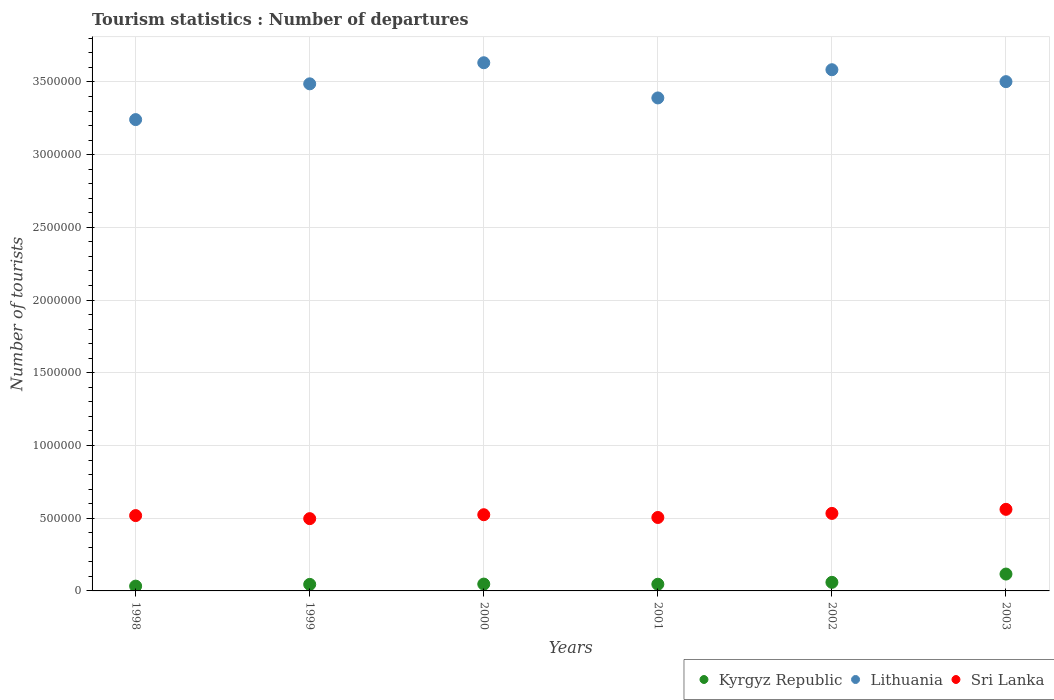Is the number of dotlines equal to the number of legend labels?
Your answer should be very brief. Yes. What is the number of tourist departures in Sri Lanka in 1999?
Keep it short and to the point. 4.97e+05. Across all years, what is the maximum number of tourist departures in Sri Lanka?
Provide a succinct answer. 5.61e+05. Across all years, what is the minimum number of tourist departures in Sri Lanka?
Offer a terse response. 4.97e+05. In which year was the number of tourist departures in Kyrgyz Republic maximum?
Your response must be concise. 2003. In which year was the number of tourist departures in Lithuania minimum?
Provide a succinct answer. 1998. What is the total number of tourist departures in Sri Lanka in the graph?
Make the answer very short. 3.14e+06. What is the difference between the number of tourist departures in Kyrgyz Republic in 2001 and that in 2003?
Keep it short and to the point. -7.00e+04. What is the difference between the number of tourist departures in Sri Lanka in 1998 and the number of tourist departures in Kyrgyz Republic in 2003?
Your answer should be very brief. 4.02e+05. What is the average number of tourist departures in Lithuania per year?
Provide a succinct answer. 3.47e+06. In the year 2001, what is the difference between the number of tourist departures in Lithuania and number of tourist departures in Kyrgyz Republic?
Give a very brief answer. 3.34e+06. What is the ratio of the number of tourist departures in Lithuania in 2000 to that in 2002?
Your response must be concise. 1.01. Is the number of tourist departures in Kyrgyz Republic in 2001 less than that in 2002?
Give a very brief answer. Yes. What is the difference between the highest and the second highest number of tourist departures in Kyrgyz Republic?
Give a very brief answer. 5.70e+04. What is the difference between the highest and the lowest number of tourist departures in Kyrgyz Republic?
Your response must be concise. 8.30e+04. Is it the case that in every year, the sum of the number of tourist departures in Kyrgyz Republic and number of tourist departures in Lithuania  is greater than the number of tourist departures in Sri Lanka?
Provide a short and direct response. Yes. Does the number of tourist departures in Lithuania monotonically increase over the years?
Ensure brevity in your answer.  No. What is the difference between two consecutive major ticks on the Y-axis?
Provide a succinct answer. 5.00e+05. Does the graph contain any zero values?
Give a very brief answer. No. How many legend labels are there?
Your answer should be very brief. 3. What is the title of the graph?
Offer a terse response. Tourism statistics : Number of departures. Does "Italy" appear as one of the legend labels in the graph?
Provide a succinct answer. No. What is the label or title of the X-axis?
Your answer should be very brief. Years. What is the label or title of the Y-axis?
Your answer should be compact. Number of tourists. What is the Number of tourists in Kyrgyz Republic in 1998?
Ensure brevity in your answer.  3.30e+04. What is the Number of tourists of Lithuania in 1998?
Your response must be concise. 3.24e+06. What is the Number of tourists of Sri Lanka in 1998?
Keep it short and to the point. 5.18e+05. What is the Number of tourists in Kyrgyz Republic in 1999?
Keep it short and to the point. 4.50e+04. What is the Number of tourists of Lithuania in 1999?
Your answer should be very brief. 3.49e+06. What is the Number of tourists in Sri Lanka in 1999?
Offer a very short reply. 4.97e+05. What is the Number of tourists of Kyrgyz Republic in 2000?
Give a very brief answer. 4.70e+04. What is the Number of tourists of Lithuania in 2000?
Your answer should be compact. 3.63e+06. What is the Number of tourists of Sri Lanka in 2000?
Give a very brief answer. 5.24e+05. What is the Number of tourists in Kyrgyz Republic in 2001?
Keep it short and to the point. 4.60e+04. What is the Number of tourists in Lithuania in 2001?
Offer a terse response. 3.39e+06. What is the Number of tourists of Sri Lanka in 2001?
Make the answer very short. 5.05e+05. What is the Number of tourists of Kyrgyz Republic in 2002?
Your answer should be very brief. 5.90e+04. What is the Number of tourists of Lithuania in 2002?
Provide a succinct answer. 3.58e+06. What is the Number of tourists of Sri Lanka in 2002?
Keep it short and to the point. 5.33e+05. What is the Number of tourists in Kyrgyz Republic in 2003?
Offer a very short reply. 1.16e+05. What is the Number of tourists of Lithuania in 2003?
Offer a terse response. 3.50e+06. What is the Number of tourists in Sri Lanka in 2003?
Your answer should be very brief. 5.61e+05. Across all years, what is the maximum Number of tourists in Kyrgyz Republic?
Give a very brief answer. 1.16e+05. Across all years, what is the maximum Number of tourists in Lithuania?
Your answer should be compact. 3.63e+06. Across all years, what is the maximum Number of tourists of Sri Lanka?
Ensure brevity in your answer.  5.61e+05. Across all years, what is the minimum Number of tourists of Kyrgyz Republic?
Offer a very short reply. 3.30e+04. Across all years, what is the minimum Number of tourists in Lithuania?
Your response must be concise. 3.24e+06. Across all years, what is the minimum Number of tourists in Sri Lanka?
Ensure brevity in your answer.  4.97e+05. What is the total Number of tourists in Kyrgyz Republic in the graph?
Your answer should be very brief. 3.46e+05. What is the total Number of tourists of Lithuania in the graph?
Your response must be concise. 2.08e+07. What is the total Number of tourists of Sri Lanka in the graph?
Ensure brevity in your answer.  3.14e+06. What is the difference between the Number of tourists of Kyrgyz Republic in 1998 and that in 1999?
Offer a terse response. -1.20e+04. What is the difference between the Number of tourists in Lithuania in 1998 and that in 1999?
Your answer should be compact. -2.46e+05. What is the difference between the Number of tourists in Sri Lanka in 1998 and that in 1999?
Your answer should be very brief. 2.10e+04. What is the difference between the Number of tourists of Kyrgyz Republic in 1998 and that in 2000?
Your answer should be compact. -1.40e+04. What is the difference between the Number of tourists in Lithuania in 1998 and that in 2000?
Your response must be concise. -3.91e+05. What is the difference between the Number of tourists in Sri Lanka in 1998 and that in 2000?
Your answer should be very brief. -6000. What is the difference between the Number of tourists of Kyrgyz Republic in 1998 and that in 2001?
Your response must be concise. -1.30e+04. What is the difference between the Number of tourists in Lithuania in 1998 and that in 2001?
Provide a short and direct response. -1.49e+05. What is the difference between the Number of tourists in Sri Lanka in 1998 and that in 2001?
Provide a succinct answer. 1.30e+04. What is the difference between the Number of tourists of Kyrgyz Republic in 1998 and that in 2002?
Offer a terse response. -2.60e+04. What is the difference between the Number of tourists in Lithuania in 1998 and that in 2002?
Offer a terse response. -3.43e+05. What is the difference between the Number of tourists of Sri Lanka in 1998 and that in 2002?
Offer a terse response. -1.50e+04. What is the difference between the Number of tourists in Kyrgyz Republic in 1998 and that in 2003?
Make the answer very short. -8.30e+04. What is the difference between the Number of tourists in Lithuania in 1998 and that in 2003?
Your answer should be very brief. -2.61e+05. What is the difference between the Number of tourists in Sri Lanka in 1998 and that in 2003?
Make the answer very short. -4.30e+04. What is the difference between the Number of tourists of Kyrgyz Republic in 1999 and that in 2000?
Offer a terse response. -2000. What is the difference between the Number of tourists in Lithuania in 1999 and that in 2000?
Provide a short and direct response. -1.45e+05. What is the difference between the Number of tourists of Sri Lanka in 1999 and that in 2000?
Make the answer very short. -2.70e+04. What is the difference between the Number of tourists of Kyrgyz Republic in 1999 and that in 2001?
Keep it short and to the point. -1000. What is the difference between the Number of tourists of Lithuania in 1999 and that in 2001?
Give a very brief answer. 9.70e+04. What is the difference between the Number of tourists in Sri Lanka in 1999 and that in 2001?
Make the answer very short. -8000. What is the difference between the Number of tourists of Kyrgyz Republic in 1999 and that in 2002?
Give a very brief answer. -1.40e+04. What is the difference between the Number of tourists in Lithuania in 1999 and that in 2002?
Offer a very short reply. -9.70e+04. What is the difference between the Number of tourists of Sri Lanka in 1999 and that in 2002?
Give a very brief answer. -3.60e+04. What is the difference between the Number of tourists of Kyrgyz Republic in 1999 and that in 2003?
Ensure brevity in your answer.  -7.10e+04. What is the difference between the Number of tourists in Lithuania in 1999 and that in 2003?
Ensure brevity in your answer.  -1.50e+04. What is the difference between the Number of tourists of Sri Lanka in 1999 and that in 2003?
Keep it short and to the point. -6.40e+04. What is the difference between the Number of tourists of Kyrgyz Republic in 2000 and that in 2001?
Your response must be concise. 1000. What is the difference between the Number of tourists of Lithuania in 2000 and that in 2001?
Your answer should be compact. 2.42e+05. What is the difference between the Number of tourists of Sri Lanka in 2000 and that in 2001?
Offer a terse response. 1.90e+04. What is the difference between the Number of tourists of Kyrgyz Republic in 2000 and that in 2002?
Provide a short and direct response. -1.20e+04. What is the difference between the Number of tourists of Lithuania in 2000 and that in 2002?
Provide a succinct answer. 4.80e+04. What is the difference between the Number of tourists of Sri Lanka in 2000 and that in 2002?
Offer a terse response. -9000. What is the difference between the Number of tourists of Kyrgyz Republic in 2000 and that in 2003?
Give a very brief answer. -6.90e+04. What is the difference between the Number of tourists in Lithuania in 2000 and that in 2003?
Provide a succinct answer. 1.30e+05. What is the difference between the Number of tourists of Sri Lanka in 2000 and that in 2003?
Provide a succinct answer. -3.70e+04. What is the difference between the Number of tourists in Kyrgyz Republic in 2001 and that in 2002?
Provide a short and direct response. -1.30e+04. What is the difference between the Number of tourists of Lithuania in 2001 and that in 2002?
Provide a short and direct response. -1.94e+05. What is the difference between the Number of tourists in Sri Lanka in 2001 and that in 2002?
Give a very brief answer. -2.80e+04. What is the difference between the Number of tourists in Kyrgyz Republic in 2001 and that in 2003?
Provide a short and direct response. -7.00e+04. What is the difference between the Number of tourists in Lithuania in 2001 and that in 2003?
Offer a terse response. -1.12e+05. What is the difference between the Number of tourists of Sri Lanka in 2001 and that in 2003?
Give a very brief answer. -5.60e+04. What is the difference between the Number of tourists of Kyrgyz Republic in 2002 and that in 2003?
Keep it short and to the point. -5.70e+04. What is the difference between the Number of tourists in Lithuania in 2002 and that in 2003?
Your response must be concise. 8.20e+04. What is the difference between the Number of tourists of Sri Lanka in 2002 and that in 2003?
Provide a succinct answer. -2.80e+04. What is the difference between the Number of tourists of Kyrgyz Republic in 1998 and the Number of tourists of Lithuania in 1999?
Offer a very short reply. -3.45e+06. What is the difference between the Number of tourists of Kyrgyz Republic in 1998 and the Number of tourists of Sri Lanka in 1999?
Your answer should be very brief. -4.64e+05. What is the difference between the Number of tourists in Lithuania in 1998 and the Number of tourists in Sri Lanka in 1999?
Ensure brevity in your answer.  2.74e+06. What is the difference between the Number of tourists in Kyrgyz Republic in 1998 and the Number of tourists in Lithuania in 2000?
Offer a very short reply. -3.60e+06. What is the difference between the Number of tourists of Kyrgyz Republic in 1998 and the Number of tourists of Sri Lanka in 2000?
Offer a terse response. -4.91e+05. What is the difference between the Number of tourists in Lithuania in 1998 and the Number of tourists in Sri Lanka in 2000?
Your response must be concise. 2.72e+06. What is the difference between the Number of tourists in Kyrgyz Republic in 1998 and the Number of tourists in Lithuania in 2001?
Give a very brief answer. -3.36e+06. What is the difference between the Number of tourists of Kyrgyz Republic in 1998 and the Number of tourists of Sri Lanka in 2001?
Provide a succinct answer. -4.72e+05. What is the difference between the Number of tourists in Lithuania in 1998 and the Number of tourists in Sri Lanka in 2001?
Your answer should be compact. 2.74e+06. What is the difference between the Number of tourists of Kyrgyz Republic in 1998 and the Number of tourists of Lithuania in 2002?
Make the answer very short. -3.55e+06. What is the difference between the Number of tourists in Kyrgyz Republic in 1998 and the Number of tourists in Sri Lanka in 2002?
Provide a short and direct response. -5.00e+05. What is the difference between the Number of tourists in Lithuania in 1998 and the Number of tourists in Sri Lanka in 2002?
Ensure brevity in your answer.  2.71e+06. What is the difference between the Number of tourists in Kyrgyz Republic in 1998 and the Number of tourists in Lithuania in 2003?
Ensure brevity in your answer.  -3.47e+06. What is the difference between the Number of tourists in Kyrgyz Republic in 1998 and the Number of tourists in Sri Lanka in 2003?
Your response must be concise. -5.28e+05. What is the difference between the Number of tourists of Lithuania in 1998 and the Number of tourists of Sri Lanka in 2003?
Provide a short and direct response. 2.68e+06. What is the difference between the Number of tourists in Kyrgyz Republic in 1999 and the Number of tourists in Lithuania in 2000?
Provide a succinct answer. -3.59e+06. What is the difference between the Number of tourists of Kyrgyz Republic in 1999 and the Number of tourists of Sri Lanka in 2000?
Make the answer very short. -4.79e+05. What is the difference between the Number of tourists of Lithuania in 1999 and the Number of tourists of Sri Lanka in 2000?
Your answer should be very brief. 2.96e+06. What is the difference between the Number of tourists of Kyrgyz Republic in 1999 and the Number of tourists of Lithuania in 2001?
Provide a succinct answer. -3.34e+06. What is the difference between the Number of tourists in Kyrgyz Republic in 1999 and the Number of tourists in Sri Lanka in 2001?
Provide a succinct answer. -4.60e+05. What is the difference between the Number of tourists in Lithuania in 1999 and the Number of tourists in Sri Lanka in 2001?
Give a very brief answer. 2.98e+06. What is the difference between the Number of tourists of Kyrgyz Republic in 1999 and the Number of tourists of Lithuania in 2002?
Give a very brief answer. -3.54e+06. What is the difference between the Number of tourists of Kyrgyz Republic in 1999 and the Number of tourists of Sri Lanka in 2002?
Offer a very short reply. -4.88e+05. What is the difference between the Number of tourists of Lithuania in 1999 and the Number of tourists of Sri Lanka in 2002?
Provide a short and direct response. 2.95e+06. What is the difference between the Number of tourists in Kyrgyz Republic in 1999 and the Number of tourists in Lithuania in 2003?
Provide a short and direct response. -3.46e+06. What is the difference between the Number of tourists of Kyrgyz Republic in 1999 and the Number of tourists of Sri Lanka in 2003?
Offer a terse response. -5.16e+05. What is the difference between the Number of tourists in Lithuania in 1999 and the Number of tourists in Sri Lanka in 2003?
Offer a terse response. 2.93e+06. What is the difference between the Number of tourists of Kyrgyz Republic in 2000 and the Number of tourists of Lithuania in 2001?
Provide a short and direct response. -3.34e+06. What is the difference between the Number of tourists of Kyrgyz Republic in 2000 and the Number of tourists of Sri Lanka in 2001?
Your answer should be very brief. -4.58e+05. What is the difference between the Number of tourists of Lithuania in 2000 and the Number of tourists of Sri Lanka in 2001?
Keep it short and to the point. 3.13e+06. What is the difference between the Number of tourists in Kyrgyz Republic in 2000 and the Number of tourists in Lithuania in 2002?
Provide a succinct answer. -3.54e+06. What is the difference between the Number of tourists in Kyrgyz Republic in 2000 and the Number of tourists in Sri Lanka in 2002?
Your response must be concise. -4.86e+05. What is the difference between the Number of tourists in Lithuania in 2000 and the Number of tourists in Sri Lanka in 2002?
Ensure brevity in your answer.  3.10e+06. What is the difference between the Number of tourists in Kyrgyz Republic in 2000 and the Number of tourists in Lithuania in 2003?
Give a very brief answer. -3.46e+06. What is the difference between the Number of tourists in Kyrgyz Republic in 2000 and the Number of tourists in Sri Lanka in 2003?
Make the answer very short. -5.14e+05. What is the difference between the Number of tourists in Lithuania in 2000 and the Number of tourists in Sri Lanka in 2003?
Keep it short and to the point. 3.07e+06. What is the difference between the Number of tourists of Kyrgyz Republic in 2001 and the Number of tourists of Lithuania in 2002?
Keep it short and to the point. -3.54e+06. What is the difference between the Number of tourists in Kyrgyz Republic in 2001 and the Number of tourists in Sri Lanka in 2002?
Give a very brief answer. -4.87e+05. What is the difference between the Number of tourists of Lithuania in 2001 and the Number of tourists of Sri Lanka in 2002?
Offer a terse response. 2.86e+06. What is the difference between the Number of tourists of Kyrgyz Republic in 2001 and the Number of tourists of Lithuania in 2003?
Provide a short and direct response. -3.46e+06. What is the difference between the Number of tourists in Kyrgyz Republic in 2001 and the Number of tourists in Sri Lanka in 2003?
Provide a succinct answer. -5.15e+05. What is the difference between the Number of tourists in Lithuania in 2001 and the Number of tourists in Sri Lanka in 2003?
Offer a very short reply. 2.83e+06. What is the difference between the Number of tourists of Kyrgyz Republic in 2002 and the Number of tourists of Lithuania in 2003?
Give a very brief answer. -3.44e+06. What is the difference between the Number of tourists in Kyrgyz Republic in 2002 and the Number of tourists in Sri Lanka in 2003?
Provide a short and direct response. -5.02e+05. What is the difference between the Number of tourists of Lithuania in 2002 and the Number of tourists of Sri Lanka in 2003?
Your response must be concise. 3.02e+06. What is the average Number of tourists of Kyrgyz Republic per year?
Provide a succinct answer. 5.77e+04. What is the average Number of tourists of Lithuania per year?
Keep it short and to the point. 3.47e+06. What is the average Number of tourists in Sri Lanka per year?
Your answer should be compact. 5.23e+05. In the year 1998, what is the difference between the Number of tourists in Kyrgyz Republic and Number of tourists in Lithuania?
Give a very brief answer. -3.21e+06. In the year 1998, what is the difference between the Number of tourists in Kyrgyz Republic and Number of tourists in Sri Lanka?
Offer a terse response. -4.85e+05. In the year 1998, what is the difference between the Number of tourists of Lithuania and Number of tourists of Sri Lanka?
Offer a very short reply. 2.72e+06. In the year 1999, what is the difference between the Number of tourists of Kyrgyz Republic and Number of tourists of Lithuania?
Provide a short and direct response. -3.44e+06. In the year 1999, what is the difference between the Number of tourists of Kyrgyz Republic and Number of tourists of Sri Lanka?
Your answer should be very brief. -4.52e+05. In the year 1999, what is the difference between the Number of tourists of Lithuania and Number of tourists of Sri Lanka?
Provide a short and direct response. 2.99e+06. In the year 2000, what is the difference between the Number of tourists of Kyrgyz Republic and Number of tourists of Lithuania?
Give a very brief answer. -3.58e+06. In the year 2000, what is the difference between the Number of tourists in Kyrgyz Republic and Number of tourists in Sri Lanka?
Give a very brief answer. -4.77e+05. In the year 2000, what is the difference between the Number of tourists in Lithuania and Number of tourists in Sri Lanka?
Give a very brief answer. 3.11e+06. In the year 2001, what is the difference between the Number of tourists of Kyrgyz Republic and Number of tourists of Lithuania?
Your answer should be compact. -3.34e+06. In the year 2001, what is the difference between the Number of tourists of Kyrgyz Republic and Number of tourists of Sri Lanka?
Give a very brief answer. -4.59e+05. In the year 2001, what is the difference between the Number of tourists in Lithuania and Number of tourists in Sri Lanka?
Your response must be concise. 2.88e+06. In the year 2002, what is the difference between the Number of tourists of Kyrgyz Republic and Number of tourists of Lithuania?
Provide a succinct answer. -3.52e+06. In the year 2002, what is the difference between the Number of tourists in Kyrgyz Republic and Number of tourists in Sri Lanka?
Your answer should be compact. -4.74e+05. In the year 2002, what is the difference between the Number of tourists of Lithuania and Number of tourists of Sri Lanka?
Your answer should be compact. 3.05e+06. In the year 2003, what is the difference between the Number of tourists in Kyrgyz Republic and Number of tourists in Lithuania?
Keep it short and to the point. -3.39e+06. In the year 2003, what is the difference between the Number of tourists of Kyrgyz Republic and Number of tourists of Sri Lanka?
Give a very brief answer. -4.45e+05. In the year 2003, what is the difference between the Number of tourists in Lithuania and Number of tourists in Sri Lanka?
Keep it short and to the point. 2.94e+06. What is the ratio of the Number of tourists of Kyrgyz Republic in 1998 to that in 1999?
Offer a terse response. 0.73. What is the ratio of the Number of tourists in Lithuania in 1998 to that in 1999?
Offer a terse response. 0.93. What is the ratio of the Number of tourists of Sri Lanka in 1998 to that in 1999?
Offer a very short reply. 1.04. What is the ratio of the Number of tourists in Kyrgyz Republic in 1998 to that in 2000?
Keep it short and to the point. 0.7. What is the ratio of the Number of tourists in Lithuania in 1998 to that in 2000?
Keep it short and to the point. 0.89. What is the ratio of the Number of tourists in Sri Lanka in 1998 to that in 2000?
Give a very brief answer. 0.99. What is the ratio of the Number of tourists in Kyrgyz Republic in 1998 to that in 2001?
Provide a succinct answer. 0.72. What is the ratio of the Number of tourists in Lithuania in 1998 to that in 2001?
Provide a succinct answer. 0.96. What is the ratio of the Number of tourists of Sri Lanka in 1998 to that in 2001?
Ensure brevity in your answer.  1.03. What is the ratio of the Number of tourists of Kyrgyz Republic in 1998 to that in 2002?
Provide a short and direct response. 0.56. What is the ratio of the Number of tourists in Lithuania in 1998 to that in 2002?
Give a very brief answer. 0.9. What is the ratio of the Number of tourists of Sri Lanka in 1998 to that in 2002?
Give a very brief answer. 0.97. What is the ratio of the Number of tourists in Kyrgyz Republic in 1998 to that in 2003?
Keep it short and to the point. 0.28. What is the ratio of the Number of tourists in Lithuania in 1998 to that in 2003?
Provide a succinct answer. 0.93. What is the ratio of the Number of tourists in Sri Lanka in 1998 to that in 2003?
Offer a very short reply. 0.92. What is the ratio of the Number of tourists of Kyrgyz Republic in 1999 to that in 2000?
Provide a succinct answer. 0.96. What is the ratio of the Number of tourists in Lithuania in 1999 to that in 2000?
Keep it short and to the point. 0.96. What is the ratio of the Number of tourists in Sri Lanka in 1999 to that in 2000?
Your answer should be compact. 0.95. What is the ratio of the Number of tourists of Kyrgyz Republic in 1999 to that in 2001?
Keep it short and to the point. 0.98. What is the ratio of the Number of tourists in Lithuania in 1999 to that in 2001?
Your answer should be very brief. 1.03. What is the ratio of the Number of tourists in Sri Lanka in 1999 to that in 2001?
Your response must be concise. 0.98. What is the ratio of the Number of tourists of Kyrgyz Republic in 1999 to that in 2002?
Your response must be concise. 0.76. What is the ratio of the Number of tourists of Lithuania in 1999 to that in 2002?
Your answer should be very brief. 0.97. What is the ratio of the Number of tourists in Sri Lanka in 1999 to that in 2002?
Your answer should be very brief. 0.93. What is the ratio of the Number of tourists in Kyrgyz Republic in 1999 to that in 2003?
Offer a very short reply. 0.39. What is the ratio of the Number of tourists of Sri Lanka in 1999 to that in 2003?
Make the answer very short. 0.89. What is the ratio of the Number of tourists in Kyrgyz Republic in 2000 to that in 2001?
Offer a terse response. 1.02. What is the ratio of the Number of tourists of Lithuania in 2000 to that in 2001?
Offer a terse response. 1.07. What is the ratio of the Number of tourists in Sri Lanka in 2000 to that in 2001?
Give a very brief answer. 1.04. What is the ratio of the Number of tourists in Kyrgyz Republic in 2000 to that in 2002?
Give a very brief answer. 0.8. What is the ratio of the Number of tourists of Lithuania in 2000 to that in 2002?
Your answer should be compact. 1.01. What is the ratio of the Number of tourists of Sri Lanka in 2000 to that in 2002?
Ensure brevity in your answer.  0.98. What is the ratio of the Number of tourists in Kyrgyz Republic in 2000 to that in 2003?
Your answer should be very brief. 0.41. What is the ratio of the Number of tourists in Lithuania in 2000 to that in 2003?
Give a very brief answer. 1.04. What is the ratio of the Number of tourists in Sri Lanka in 2000 to that in 2003?
Keep it short and to the point. 0.93. What is the ratio of the Number of tourists in Kyrgyz Republic in 2001 to that in 2002?
Keep it short and to the point. 0.78. What is the ratio of the Number of tourists of Lithuania in 2001 to that in 2002?
Make the answer very short. 0.95. What is the ratio of the Number of tourists of Sri Lanka in 2001 to that in 2002?
Ensure brevity in your answer.  0.95. What is the ratio of the Number of tourists in Kyrgyz Republic in 2001 to that in 2003?
Keep it short and to the point. 0.4. What is the ratio of the Number of tourists of Lithuania in 2001 to that in 2003?
Offer a very short reply. 0.97. What is the ratio of the Number of tourists of Sri Lanka in 2001 to that in 2003?
Your answer should be compact. 0.9. What is the ratio of the Number of tourists of Kyrgyz Republic in 2002 to that in 2003?
Give a very brief answer. 0.51. What is the ratio of the Number of tourists of Lithuania in 2002 to that in 2003?
Your answer should be very brief. 1.02. What is the ratio of the Number of tourists of Sri Lanka in 2002 to that in 2003?
Your answer should be compact. 0.95. What is the difference between the highest and the second highest Number of tourists in Kyrgyz Republic?
Ensure brevity in your answer.  5.70e+04. What is the difference between the highest and the second highest Number of tourists in Lithuania?
Your response must be concise. 4.80e+04. What is the difference between the highest and the second highest Number of tourists of Sri Lanka?
Give a very brief answer. 2.80e+04. What is the difference between the highest and the lowest Number of tourists in Kyrgyz Republic?
Offer a very short reply. 8.30e+04. What is the difference between the highest and the lowest Number of tourists in Lithuania?
Offer a terse response. 3.91e+05. What is the difference between the highest and the lowest Number of tourists of Sri Lanka?
Give a very brief answer. 6.40e+04. 